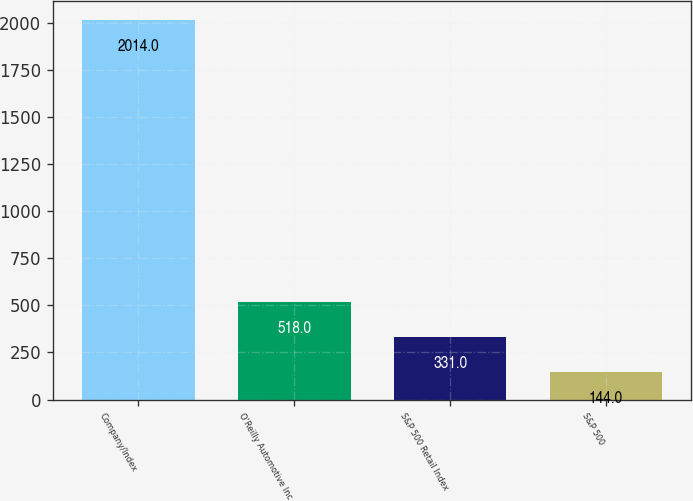<chart> <loc_0><loc_0><loc_500><loc_500><bar_chart><fcel>Company/Index<fcel>O'Reilly Automotive Inc<fcel>S&P 500 Retail Index<fcel>S&P 500<nl><fcel>2014<fcel>518<fcel>331<fcel>144<nl></chart> 